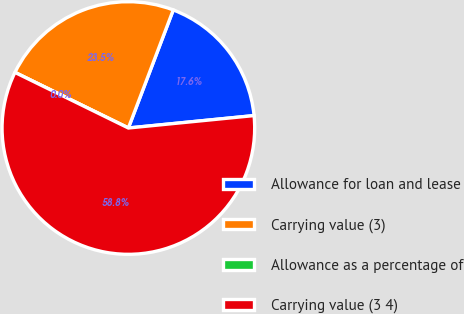<chart> <loc_0><loc_0><loc_500><loc_500><pie_chart><fcel>Allowance for loan and lease<fcel>Carrying value (3)<fcel>Allowance as a percentage of<fcel>Carrying value (3 4)<nl><fcel>17.65%<fcel>23.53%<fcel>0.0%<fcel>58.82%<nl></chart> 